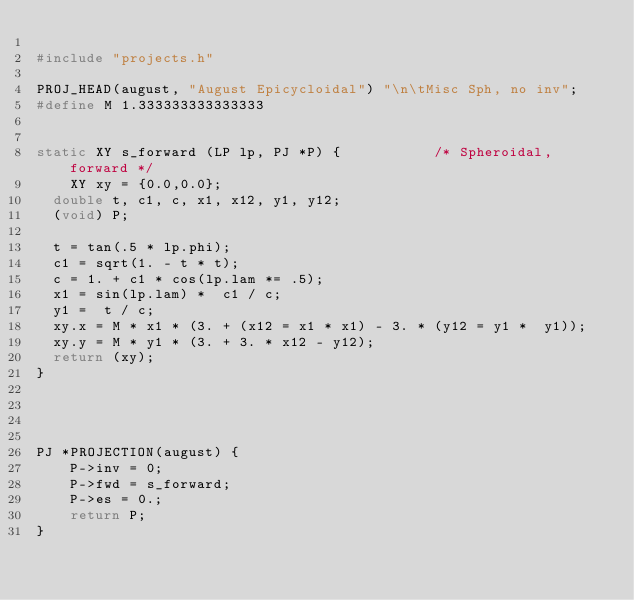Convert code to text. <code><loc_0><loc_0><loc_500><loc_500><_C_>
#include "projects.h"

PROJ_HEAD(august, "August Epicycloidal") "\n\tMisc Sph, no inv";
#define M 1.333333333333333


static XY s_forward (LP lp, PJ *P) {           /* Spheroidal, forward */
    XY xy = {0.0,0.0};
	double t, c1, c, x1, x12, y1, y12;
	(void) P;

	t = tan(.5 * lp.phi);
	c1 = sqrt(1. - t * t);
	c = 1. + c1 * cos(lp.lam *= .5);
	x1 = sin(lp.lam) *  c1 / c;
	y1 =  t / c;
	xy.x = M * x1 * (3. + (x12 = x1 * x1) - 3. * (y12 = y1 *  y1));
	xy.y = M * y1 * (3. + 3. * x12 - y12);
	return (xy);
}




PJ *PROJECTION(august) {
    P->inv = 0;
    P->fwd = s_forward;
    P->es = 0.;
    return P;
}
</code> 